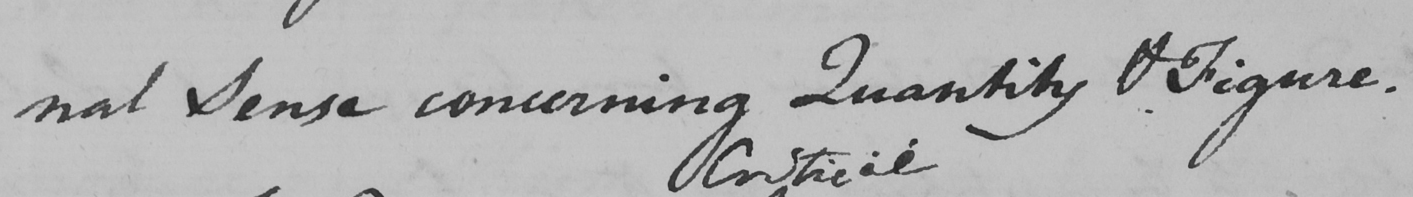Can you read and transcribe this handwriting? -nal Sense concerning Quantity & Figure . 